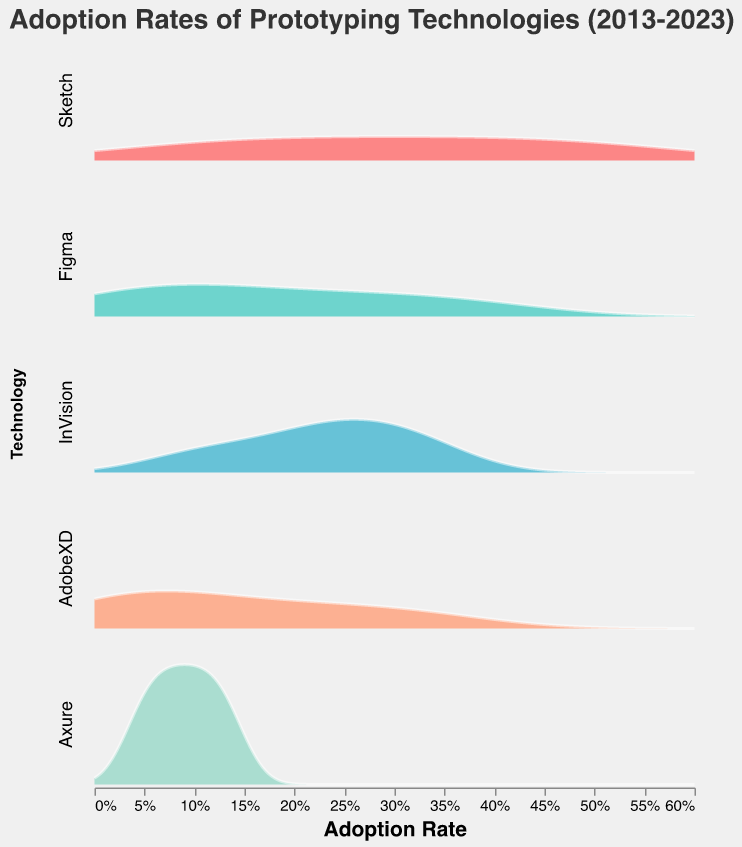What is the adoption rate of Sketch in 2013? Look at the facet plot for Sketch and find the data point corresponding to 2013. The adoption rate is 0.05.
Answer: 0.05 Which technology has the highest adoption rate in 2023? Compare the adoption rates across different technologies in 2023. Sketch has the highest adoption rate of 0.55.
Answer: Sketch How has the adoption rate of Figma changed from 2013 to 2023? Track the adoption rates of Figma from 2013 to 2023. It increased from 0.02 in 2013 to 0.40 in 2023.
Answer: Increased Which technology shows the most consistent increase in adoption rate over the decade? Observe the adoption rate trends for each technology over the decade. Sketch shows a consistent increase in adoption rate.
Answer: Sketch What is the median adoption rate of AdobeXD over the decade? List the yearly adoption rates of AdobeXD: 0.01, 0.02, 0.03, 0.05, 0.08, 0.12, 0.16, 0.20, 0.25, 0.30, 0.35. The median is the middle value: 0.12.
Answer: 0.12 Is the adoption rate of InVision in 2019 higher or lower than its rate in 2018? Compare the rates for InVision in 2019 (0.26) and 2018 (0.24). The rate in 2019 is higher.
Answer: Higher Which year shows the largest increase in adoption rate for Sketch compared to the previous year? Calculate the differences in adoption rate for Sketch year-over-year. The largest increase is between 2017 (0.25) and 2018 (0.30), a difference of 0.05.
Answer: 2018 What is the general trend observed for Axure over the decade? Chart the adoption rates of Axure from 2013 to 2023. The rates show a slight but steady increase over the period.
Answer: Steady increase 